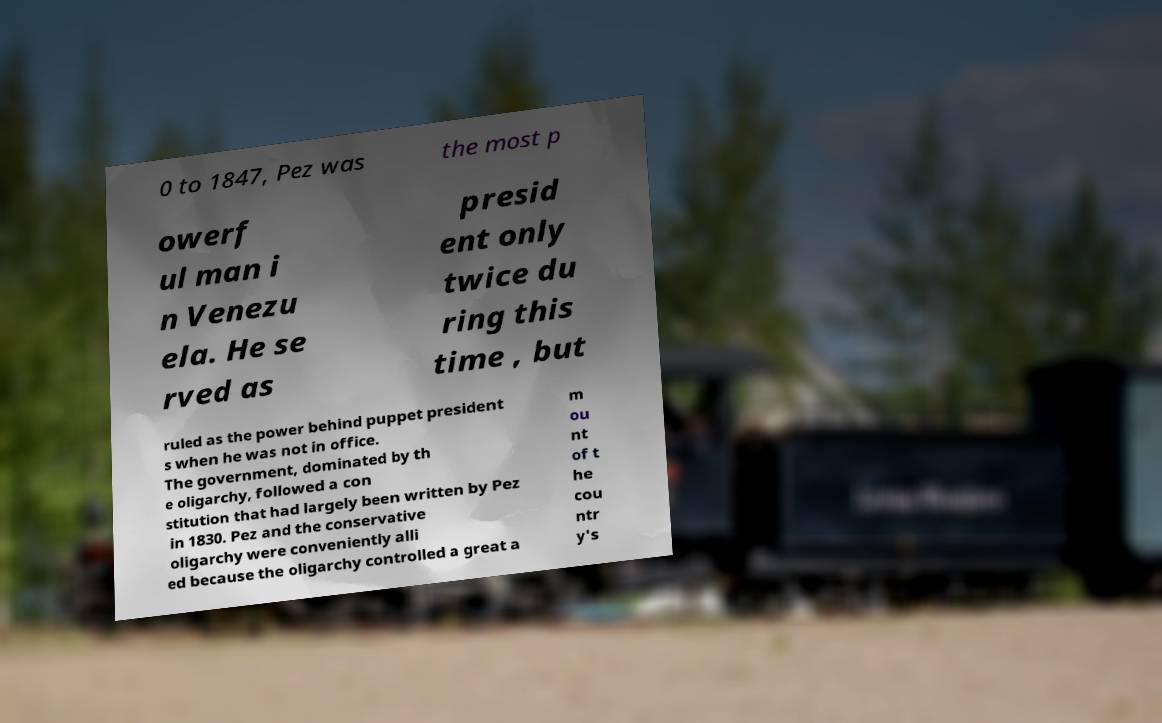I need the written content from this picture converted into text. Can you do that? 0 to 1847, Pez was the most p owerf ul man i n Venezu ela. He se rved as presid ent only twice du ring this time , but ruled as the power behind puppet president s when he was not in office. The government, dominated by th e oligarchy, followed a con stitution that had largely been written by Pez in 1830. Pez and the conservative oligarchy were conveniently alli ed because the oligarchy controlled a great a m ou nt of t he cou ntr y's 